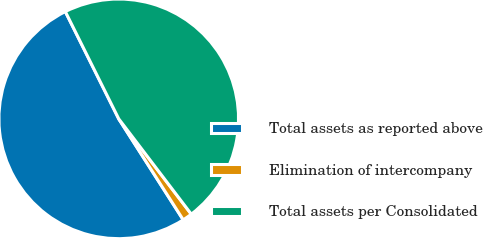Convert chart. <chart><loc_0><loc_0><loc_500><loc_500><pie_chart><fcel>Total assets as reported above<fcel>Elimination of intercompany<fcel>Total assets per Consolidated<nl><fcel>51.7%<fcel>1.31%<fcel>47.0%<nl></chart> 